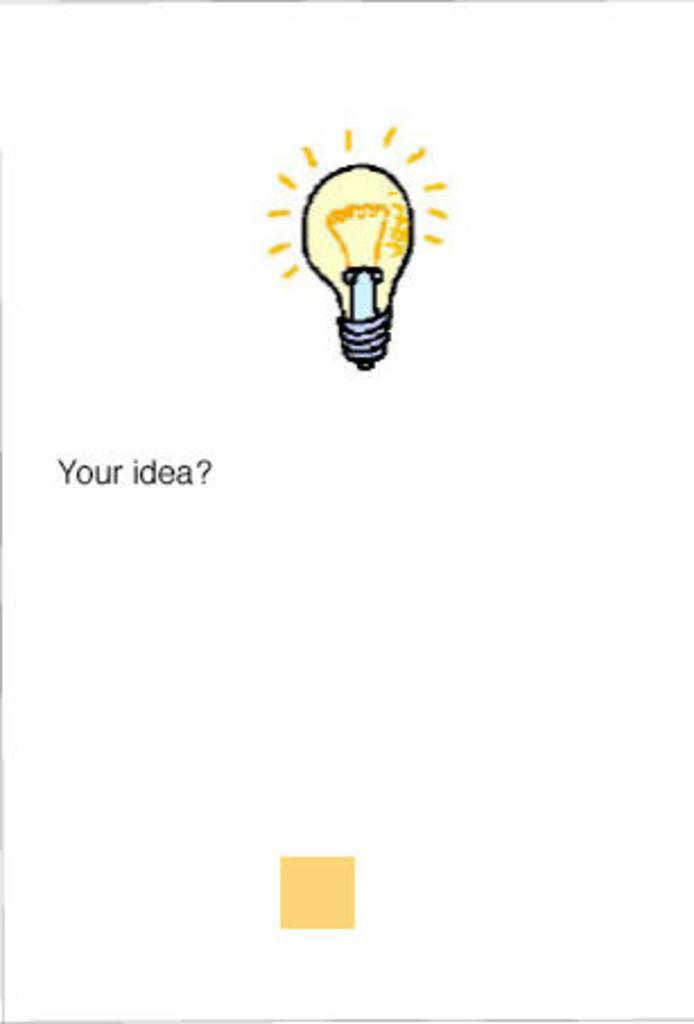What is happening in the main image? There is a picture of a bulb lighting in the image. What else can be seen on the left side of the image? There is text on the left side of the image. What shape is present at the bottom of the image? There is a square at the bottom of the image. What type of soda is being poured into the glass in the image? There is no glass or soda present in the image; it features a picture of a bulb lighting, text on the left side, and a square at the bottom. How many rings are visible on the person's finger in the image? There are no people or rings present in the image. 